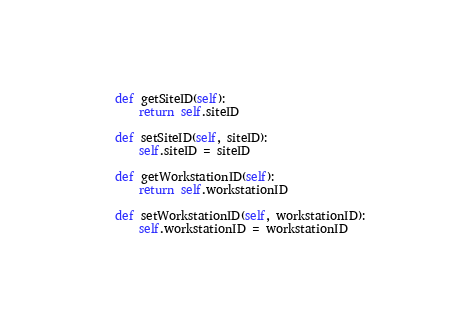<code> <loc_0><loc_0><loc_500><loc_500><_Python_>    def getSiteID(self):
        return self.siteID

    def setSiteID(self, siteID):
        self.siteID = siteID

    def getWorkstationID(self):
        return self.workstationID

    def setWorkstationID(self, workstationID):
        self.workstationID = workstationID
</code> 